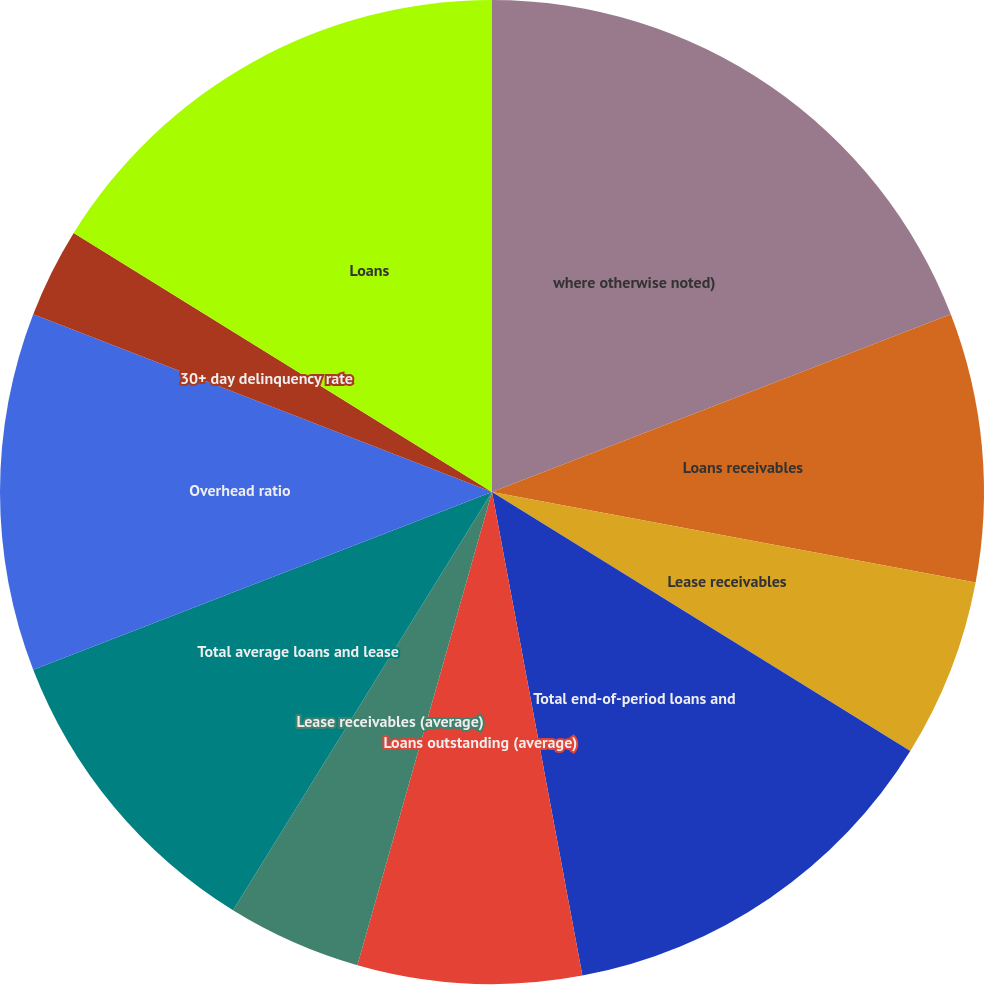<chart> <loc_0><loc_0><loc_500><loc_500><pie_chart><fcel>where otherwise noted)<fcel>Loans receivables<fcel>Lease receivables<fcel>Total end-of-period loans and<fcel>Loans outstanding (average)<fcel>Lease receivables (average)<fcel>Total average loans and lease<fcel>Overhead ratio<fcel>30+ day delinquency rate<fcel>Loans<nl><fcel>19.11%<fcel>8.82%<fcel>5.88%<fcel>13.23%<fcel>7.35%<fcel>4.41%<fcel>10.29%<fcel>11.76%<fcel>2.94%<fcel>16.17%<nl></chart> 